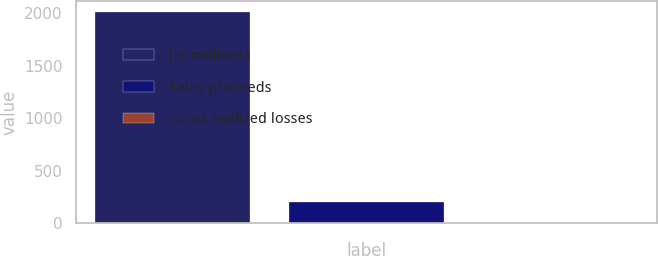<chart> <loc_0><loc_0><loc_500><loc_500><bar_chart><fcel>(in millions)<fcel>Sales proceeds<fcel>Gross realized losses<nl><fcel>2014<fcel>204.1<fcel>3<nl></chart> 